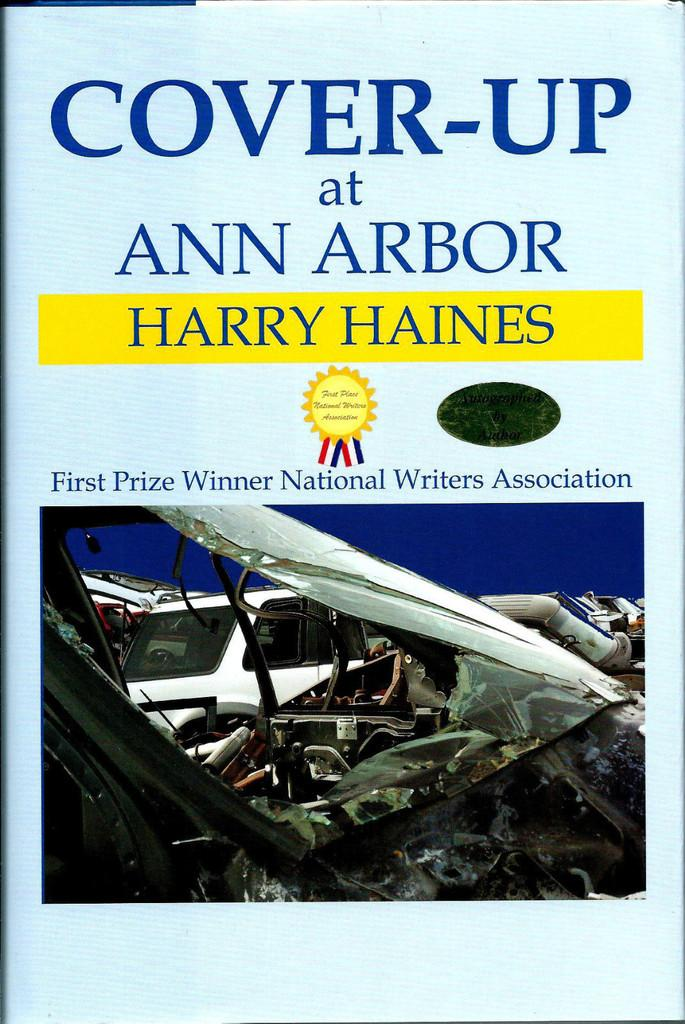<image>
Render a clear and concise summary of the photo. The Harry Haines book "Cover Up at Ann Arbor" won first prize from the National Writers Association. 